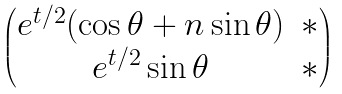<formula> <loc_0><loc_0><loc_500><loc_500>\begin{pmatrix} e ^ { t / 2 } ( \cos \theta + n \sin \theta ) & \ast \\ e ^ { t / 2 } \sin \theta & \ast \end{pmatrix}</formula> 